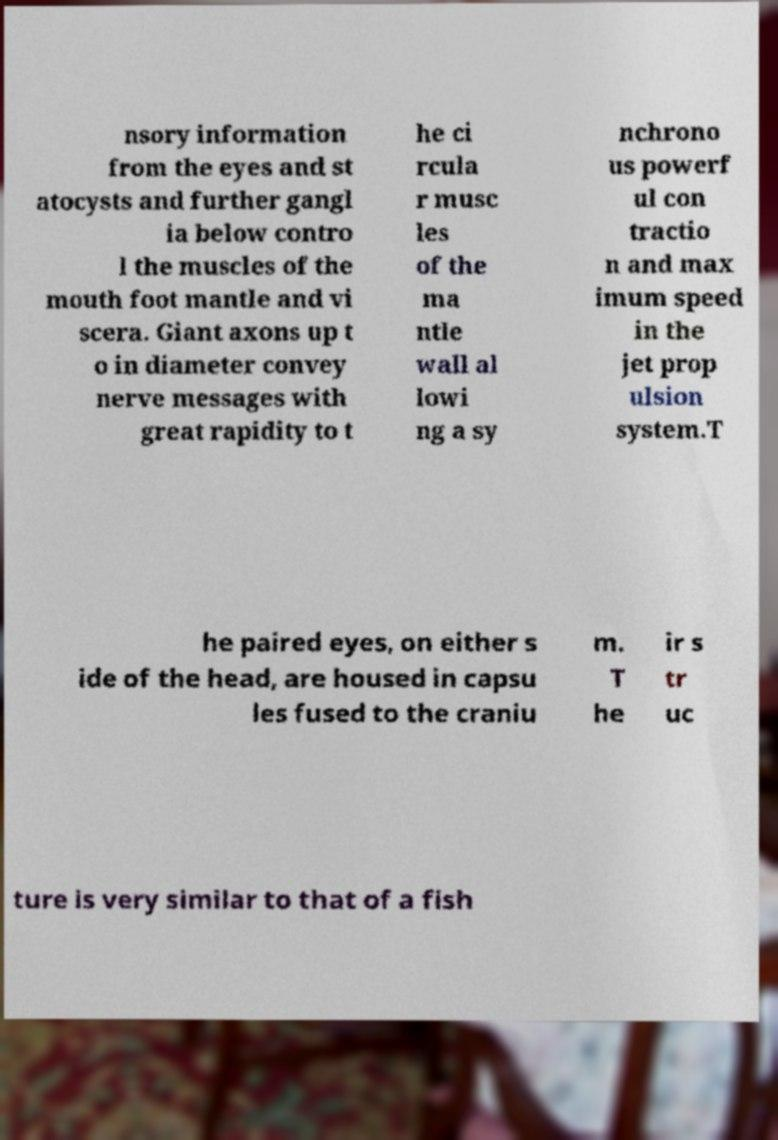Please identify and transcribe the text found in this image. nsory information from the eyes and st atocysts and further gangl ia below contro l the muscles of the mouth foot mantle and vi scera. Giant axons up t o in diameter convey nerve messages with great rapidity to t he ci rcula r musc les of the ma ntle wall al lowi ng a sy nchrono us powerf ul con tractio n and max imum speed in the jet prop ulsion system.T he paired eyes, on either s ide of the head, are housed in capsu les fused to the craniu m. T he ir s tr uc ture is very similar to that of a fish 